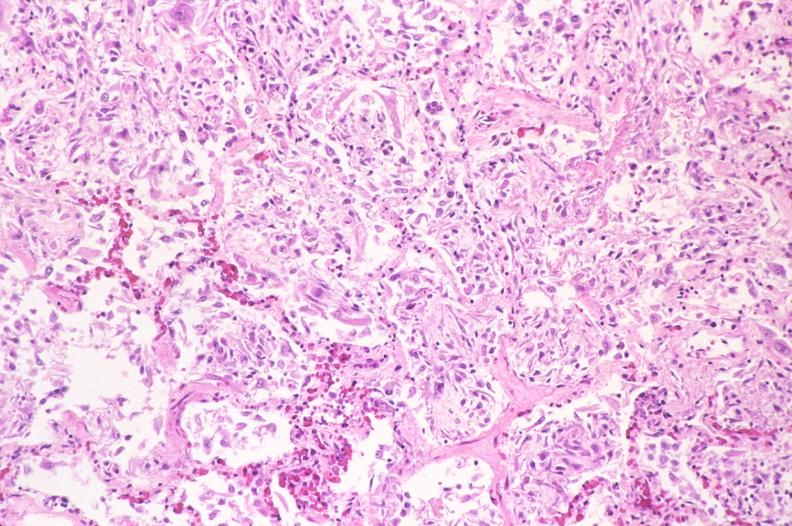does this image show lung, diffuse alveolar damage?
Answer the question using a single word or phrase. Yes 